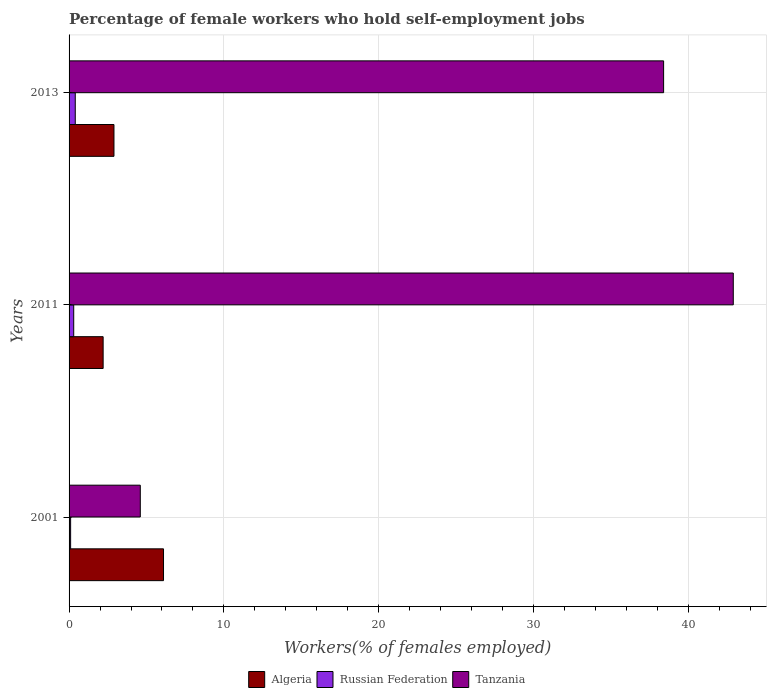How many different coloured bars are there?
Your response must be concise. 3. Are the number of bars on each tick of the Y-axis equal?
Ensure brevity in your answer.  Yes. In how many cases, is the number of bars for a given year not equal to the number of legend labels?
Keep it short and to the point. 0. What is the percentage of self-employed female workers in Tanzania in 2001?
Offer a very short reply. 4.6. Across all years, what is the maximum percentage of self-employed female workers in Tanzania?
Give a very brief answer. 42.9. Across all years, what is the minimum percentage of self-employed female workers in Tanzania?
Keep it short and to the point. 4.6. What is the total percentage of self-employed female workers in Russian Federation in the graph?
Make the answer very short. 0.8. What is the difference between the percentage of self-employed female workers in Russian Federation in 2001 and that in 2011?
Offer a terse response. -0.2. What is the difference between the percentage of self-employed female workers in Tanzania in 2013 and the percentage of self-employed female workers in Russian Federation in 2001?
Provide a succinct answer. 38.3. What is the average percentage of self-employed female workers in Russian Federation per year?
Ensure brevity in your answer.  0.27. In the year 2011, what is the difference between the percentage of self-employed female workers in Russian Federation and percentage of self-employed female workers in Algeria?
Keep it short and to the point. -1.9. In how many years, is the percentage of self-employed female workers in Tanzania greater than 24 %?
Offer a terse response. 2. What is the ratio of the percentage of self-employed female workers in Tanzania in 2001 to that in 2013?
Give a very brief answer. 0.12. What is the difference between the highest and the lowest percentage of self-employed female workers in Algeria?
Your answer should be very brief. 3.9. In how many years, is the percentage of self-employed female workers in Algeria greater than the average percentage of self-employed female workers in Algeria taken over all years?
Keep it short and to the point. 1. What does the 1st bar from the top in 2013 represents?
Offer a terse response. Tanzania. What does the 1st bar from the bottom in 2011 represents?
Your answer should be compact. Algeria. Is it the case that in every year, the sum of the percentage of self-employed female workers in Russian Federation and percentage of self-employed female workers in Tanzania is greater than the percentage of self-employed female workers in Algeria?
Offer a terse response. No. Are all the bars in the graph horizontal?
Your answer should be very brief. Yes. Are the values on the major ticks of X-axis written in scientific E-notation?
Your answer should be very brief. No. Does the graph contain any zero values?
Offer a terse response. No. How many legend labels are there?
Your response must be concise. 3. What is the title of the graph?
Keep it short and to the point. Percentage of female workers who hold self-employment jobs. Does "Antigua and Barbuda" appear as one of the legend labels in the graph?
Your response must be concise. No. What is the label or title of the X-axis?
Offer a very short reply. Workers(% of females employed). What is the Workers(% of females employed) in Algeria in 2001?
Offer a very short reply. 6.1. What is the Workers(% of females employed) of Russian Federation in 2001?
Make the answer very short. 0.1. What is the Workers(% of females employed) of Tanzania in 2001?
Your answer should be very brief. 4.6. What is the Workers(% of females employed) of Algeria in 2011?
Offer a terse response. 2.2. What is the Workers(% of females employed) of Russian Federation in 2011?
Your answer should be compact. 0.3. What is the Workers(% of females employed) in Tanzania in 2011?
Make the answer very short. 42.9. What is the Workers(% of females employed) in Algeria in 2013?
Make the answer very short. 2.9. What is the Workers(% of females employed) of Russian Federation in 2013?
Your answer should be compact. 0.4. What is the Workers(% of females employed) of Tanzania in 2013?
Your answer should be compact. 38.4. Across all years, what is the maximum Workers(% of females employed) in Algeria?
Provide a short and direct response. 6.1. Across all years, what is the maximum Workers(% of females employed) in Russian Federation?
Keep it short and to the point. 0.4. Across all years, what is the maximum Workers(% of females employed) of Tanzania?
Provide a short and direct response. 42.9. Across all years, what is the minimum Workers(% of females employed) of Algeria?
Your answer should be very brief. 2.2. Across all years, what is the minimum Workers(% of females employed) of Russian Federation?
Your answer should be compact. 0.1. Across all years, what is the minimum Workers(% of females employed) in Tanzania?
Your answer should be very brief. 4.6. What is the total Workers(% of females employed) of Russian Federation in the graph?
Provide a succinct answer. 0.8. What is the total Workers(% of females employed) in Tanzania in the graph?
Provide a succinct answer. 85.9. What is the difference between the Workers(% of females employed) of Algeria in 2001 and that in 2011?
Your response must be concise. 3.9. What is the difference between the Workers(% of females employed) of Tanzania in 2001 and that in 2011?
Your answer should be very brief. -38.3. What is the difference between the Workers(% of females employed) of Algeria in 2001 and that in 2013?
Offer a very short reply. 3.2. What is the difference between the Workers(% of females employed) of Tanzania in 2001 and that in 2013?
Ensure brevity in your answer.  -33.8. What is the difference between the Workers(% of females employed) in Algeria in 2011 and that in 2013?
Provide a succinct answer. -0.7. What is the difference between the Workers(% of females employed) of Tanzania in 2011 and that in 2013?
Offer a very short reply. 4.5. What is the difference between the Workers(% of females employed) in Algeria in 2001 and the Workers(% of females employed) in Russian Federation in 2011?
Offer a very short reply. 5.8. What is the difference between the Workers(% of females employed) of Algeria in 2001 and the Workers(% of females employed) of Tanzania in 2011?
Keep it short and to the point. -36.8. What is the difference between the Workers(% of females employed) in Russian Federation in 2001 and the Workers(% of females employed) in Tanzania in 2011?
Make the answer very short. -42.8. What is the difference between the Workers(% of females employed) of Algeria in 2001 and the Workers(% of females employed) of Tanzania in 2013?
Make the answer very short. -32.3. What is the difference between the Workers(% of females employed) of Russian Federation in 2001 and the Workers(% of females employed) of Tanzania in 2013?
Offer a terse response. -38.3. What is the difference between the Workers(% of females employed) in Algeria in 2011 and the Workers(% of females employed) in Tanzania in 2013?
Your answer should be very brief. -36.2. What is the difference between the Workers(% of females employed) in Russian Federation in 2011 and the Workers(% of females employed) in Tanzania in 2013?
Provide a succinct answer. -38.1. What is the average Workers(% of females employed) of Algeria per year?
Your answer should be very brief. 3.73. What is the average Workers(% of females employed) in Russian Federation per year?
Your answer should be compact. 0.27. What is the average Workers(% of females employed) of Tanzania per year?
Provide a succinct answer. 28.63. In the year 2001, what is the difference between the Workers(% of females employed) in Algeria and Workers(% of females employed) in Tanzania?
Keep it short and to the point. 1.5. In the year 2001, what is the difference between the Workers(% of females employed) in Russian Federation and Workers(% of females employed) in Tanzania?
Your answer should be very brief. -4.5. In the year 2011, what is the difference between the Workers(% of females employed) in Algeria and Workers(% of females employed) in Russian Federation?
Ensure brevity in your answer.  1.9. In the year 2011, what is the difference between the Workers(% of females employed) of Algeria and Workers(% of females employed) of Tanzania?
Offer a very short reply. -40.7. In the year 2011, what is the difference between the Workers(% of females employed) of Russian Federation and Workers(% of females employed) of Tanzania?
Your answer should be compact. -42.6. In the year 2013, what is the difference between the Workers(% of females employed) of Algeria and Workers(% of females employed) of Russian Federation?
Keep it short and to the point. 2.5. In the year 2013, what is the difference between the Workers(% of females employed) of Algeria and Workers(% of females employed) of Tanzania?
Offer a terse response. -35.5. In the year 2013, what is the difference between the Workers(% of females employed) of Russian Federation and Workers(% of females employed) of Tanzania?
Keep it short and to the point. -38. What is the ratio of the Workers(% of females employed) in Algeria in 2001 to that in 2011?
Offer a terse response. 2.77. What is the ratio of the Workers(% of females employed) of Russian Federation in 2001 to that in 2011?
Offer a very short reply. 0.33. What is the ratio of the Workers(% of females employed) of Tanzania in 2001 to that in 2011?
Provide a succinct answer. 0.11. What is the ratio of the Workers(% of females employed) in Algeria in 2001 to that in 2013?
Offer a very short reply. 2.1. What is the ratio of the Workers(% of females employed) of Tanzania in 2001 to that in 2013?
Provide a short and direct response. 0.12. What is the ratio of the Workers(% of females employed) in Algeria in 2011 to that in 2013?
Provide a succinct answer. 0.76. What is the ratio of the Workers(% of females employed) of Tanzania in 2011 to that in 2013?
Provide a succinct answer. 1.12. What is the difference between the highest and the lowest Workers(% of females employed) of Russian Federation?
Ensure brevity in your answer.  0.3. What is the difference between the highest and the lowest Workers(% of females employed) in Tanzania?
Your response must be concise. 38.3. 